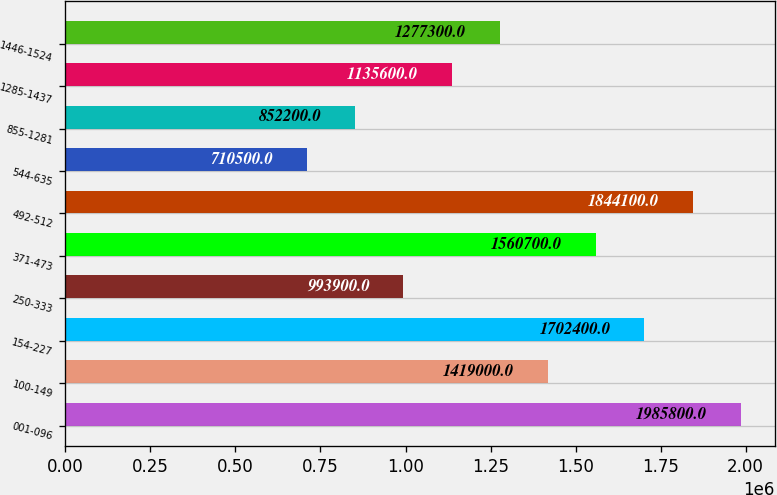Convert chart to OTSL. <chart><loc_0><loc_0><loc_500><loc_500><bar_chart><fcel>001-096<fcel>100-149<fcel>154-227<fcel>250-333<fcel>371-473<fcel>492-512<fcel>544-635<fcel>855-1281<fcel>1285-1437<fcel>1446-1524<nl><fcel>1.9858e+06<fcel>1.419e+06<fcel>1.7024e+06<fcel>993900<fcel>1.5607e+06<fcel>1.8441e+06<fcel>710500<fcel>852200<fcel>1.1356e+06<fcel>1.2773e+06<nl></chart> 